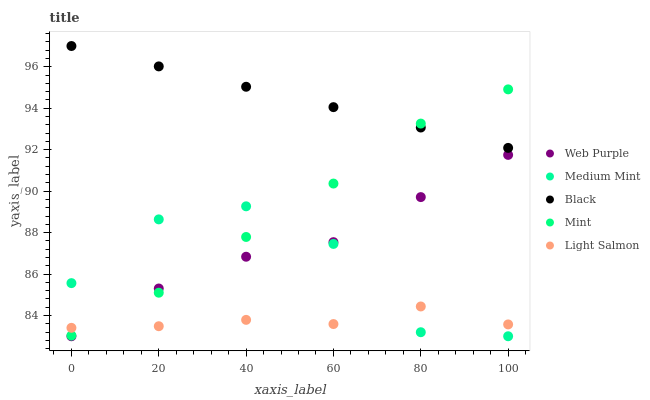Does Light Salmon have the minimum area under the curve?
Answer yes or no. Yes. Does Black have the maximum area under the curve?
Answer yes or no. Yes. Does Mint have the minimum area under the curve?
Answer yes or no. No. Does Mint have the maximum area under the curve?
Answer yes or no. No. Is Black the smoothest?
Answer yes or no. Yes. Is Medium Mint the roughest?
Answer yes or no. Yes. Is Mint the smoothest?
Answer yes or no. No. Is Mint the roughest?
Answer yes or no. No. Does Medium Mint have the lowest value?
Answer yes or no. Yes. Does Mint have the lowest value?
Answer yes or no. No. Does Black have the highest value?
Answer yes or no. Yes. Does Mint have the highest value?
Answer yes or no. No. Is Medium Mint less than Black?
Answer yes or no. Yes. Is Black greater than Medium Mint?
Answer yes or no. Yes. Does Web Purple intersect Medium Mint?
Answer yes or no. Yes. Is Web Purple less than Medium Mint?
Answer yes or no. No. Is Web Purple greater than Medium Mint?
Answer yes or no. No. Does Medium Mint intersect Black?
Answer yes or no. No. 